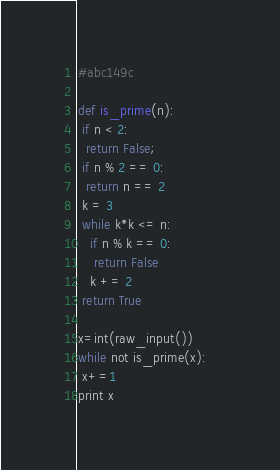<code> <loc_0><loc_0><loc_500><loc_500><_Python_>#abc149c

def is_prime(n):
 if n < 2: 
  return False;
 if n % 2 == 0:             
  return n == 2
 k = 3
 while k*k <= n:
   if n % k == 0:
    return False
   k += 2
 return True

x=int(raw_input())
while not is_prime(x):
 x+=1
print x
</code> 